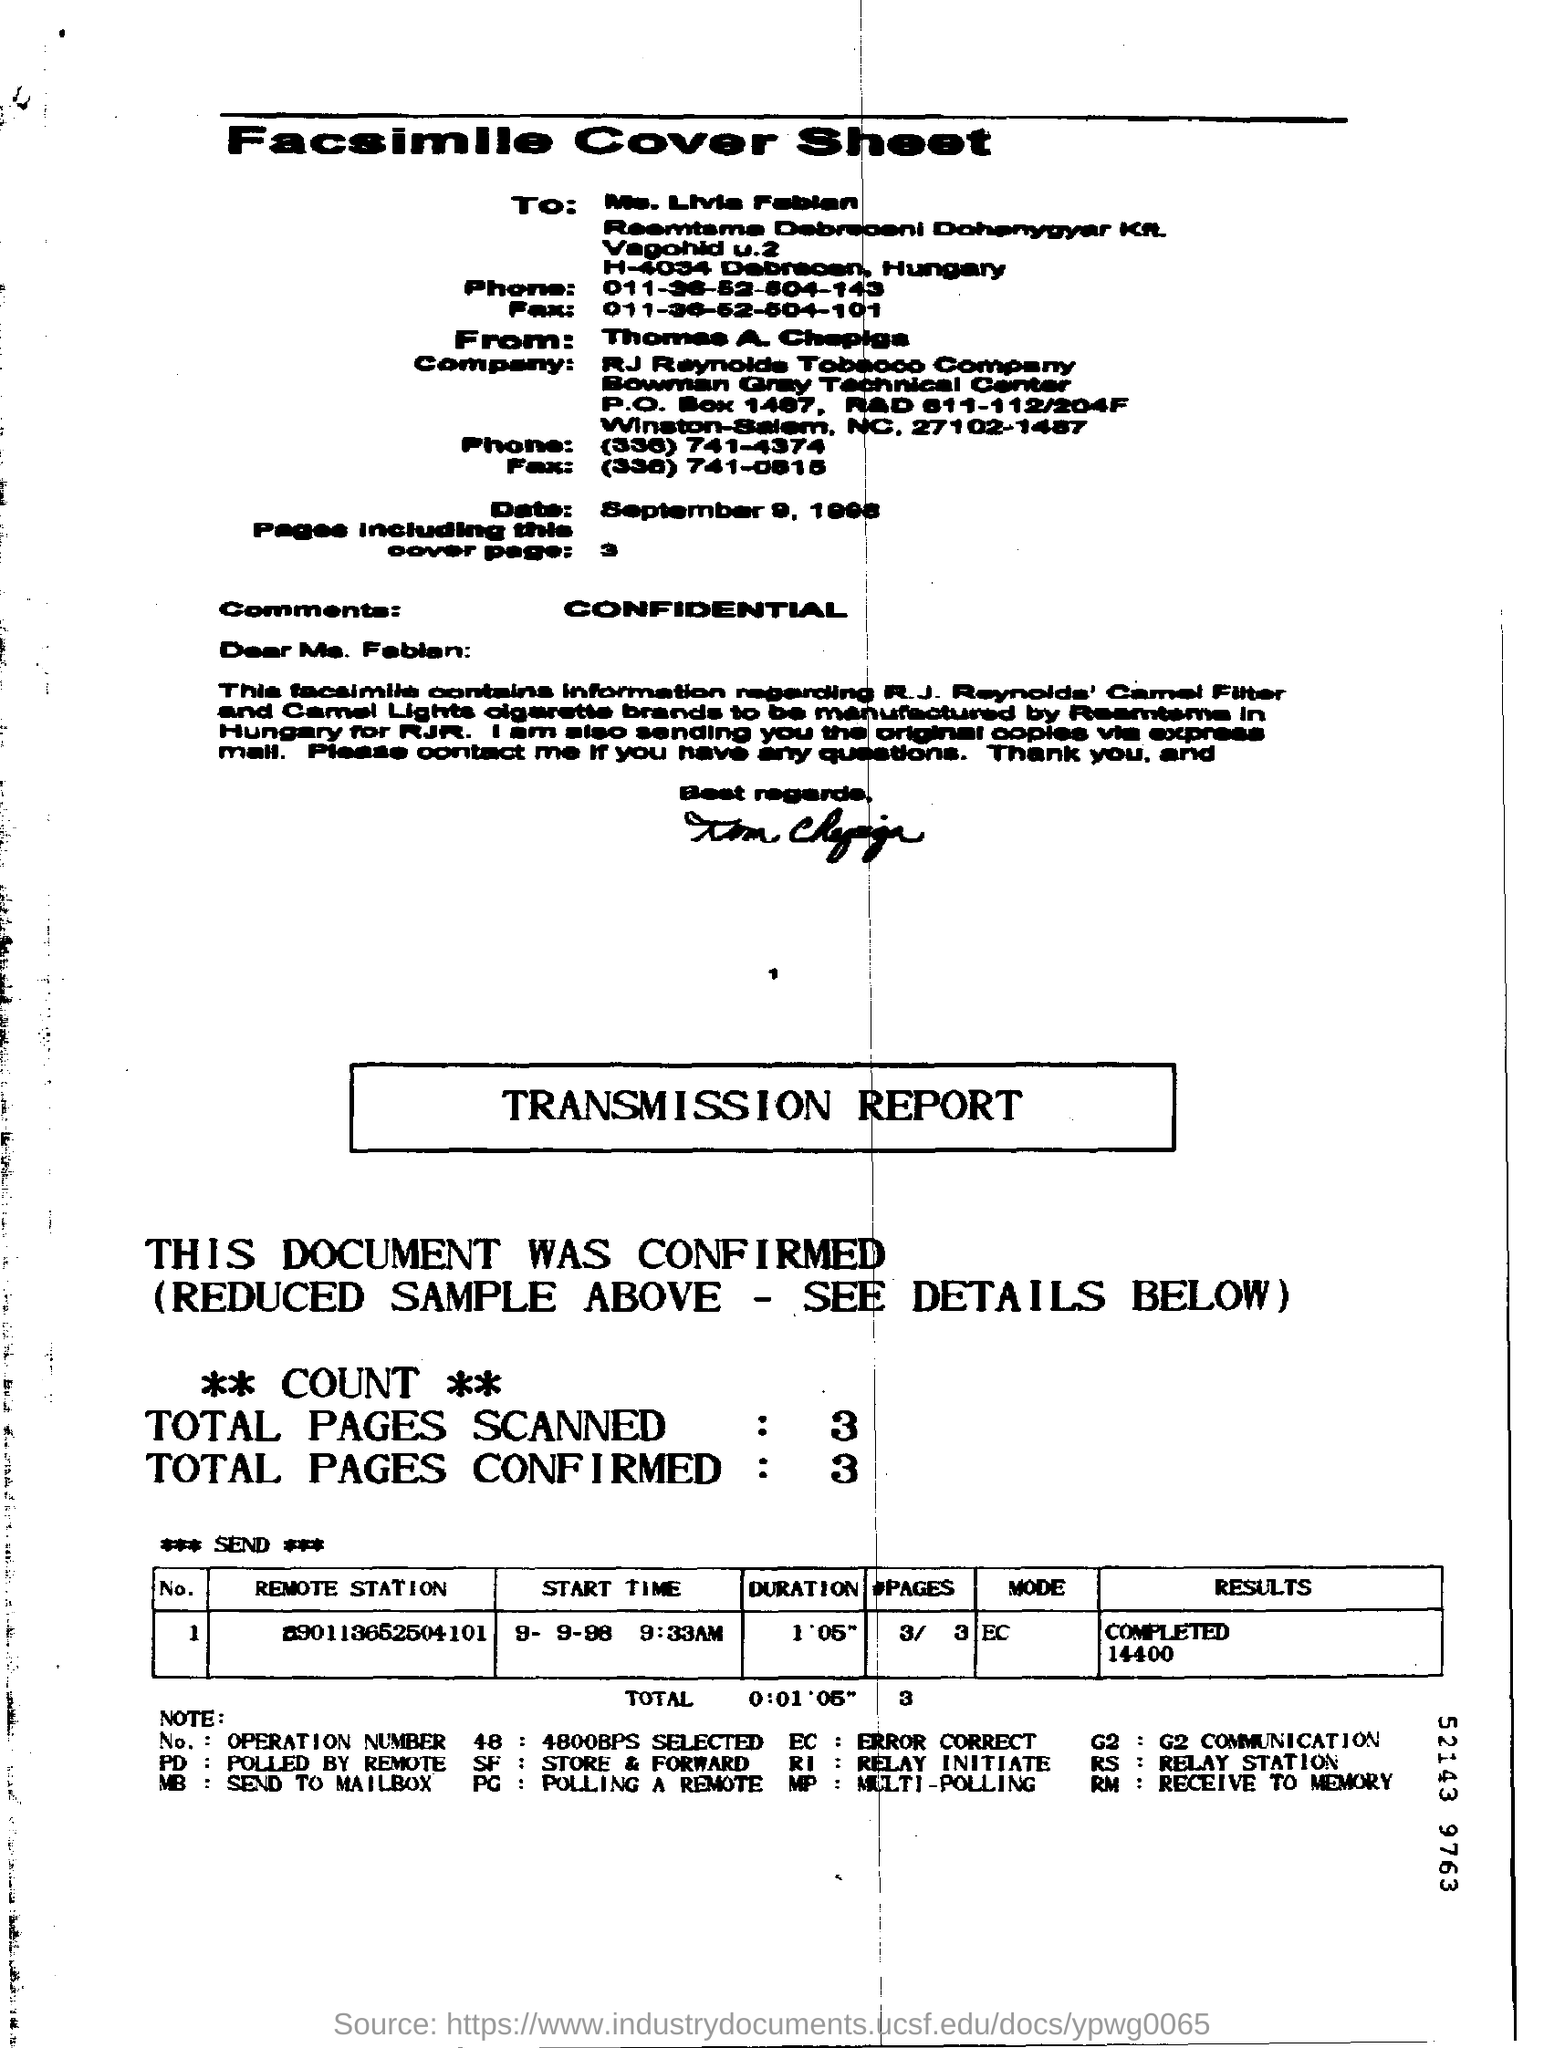Indicate a few pertinent items in this graphic. What is written as comments? Confidential... This document contains three pages, including the cover page. 